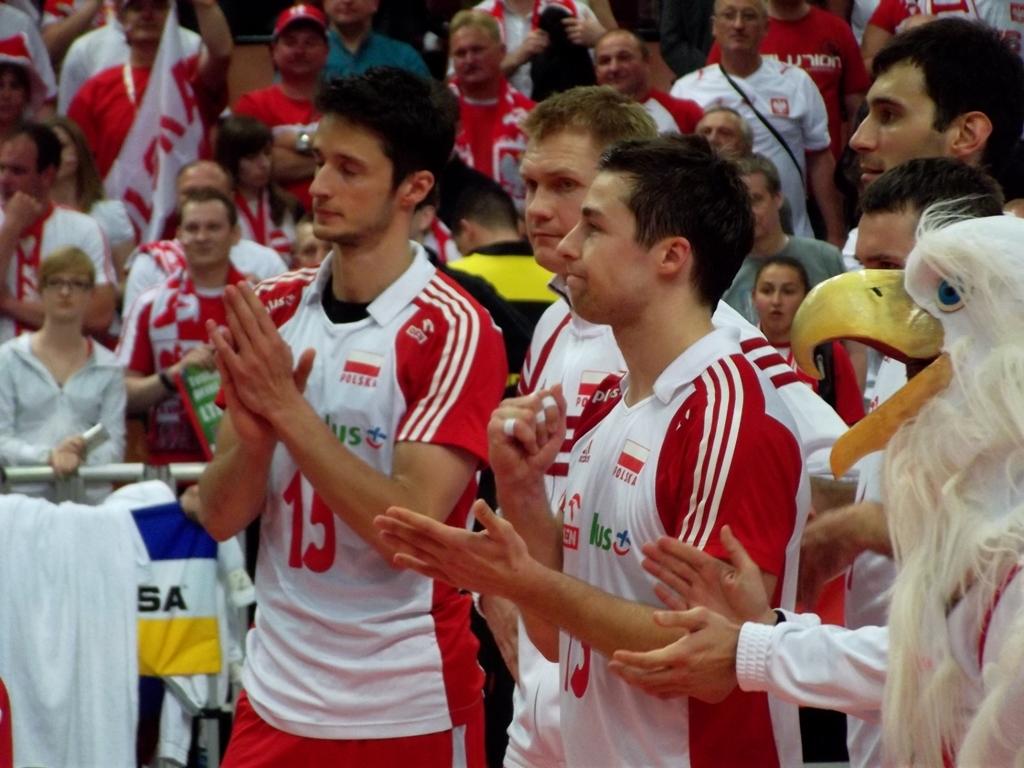What number is visible on the man on the left?
Your answer should be compact. 15. 